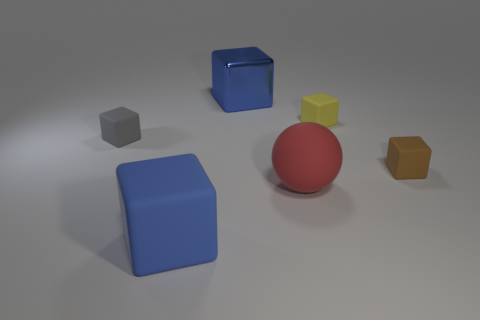Subtract all gray blocks. How many blocks are left? 4 Subtract all blue shiny blocks. How many blocks are left? 4 Subtract all purple cubes. Subtract all red cylinders. How many cubes are left? 5 Add 2 brown matte blocks. How many objects exist? 8 Subtract all spheres. How many objects are left? 5 Add 5 yellow objects. How many yellow objects exist? 6 Subtract 0 brown balls. How many objects are left? 6 Subtract all red rubber things. Subtract all red cylinders. How many objects are left? 5 Add 2 red balls. How many red balls are left? 3 